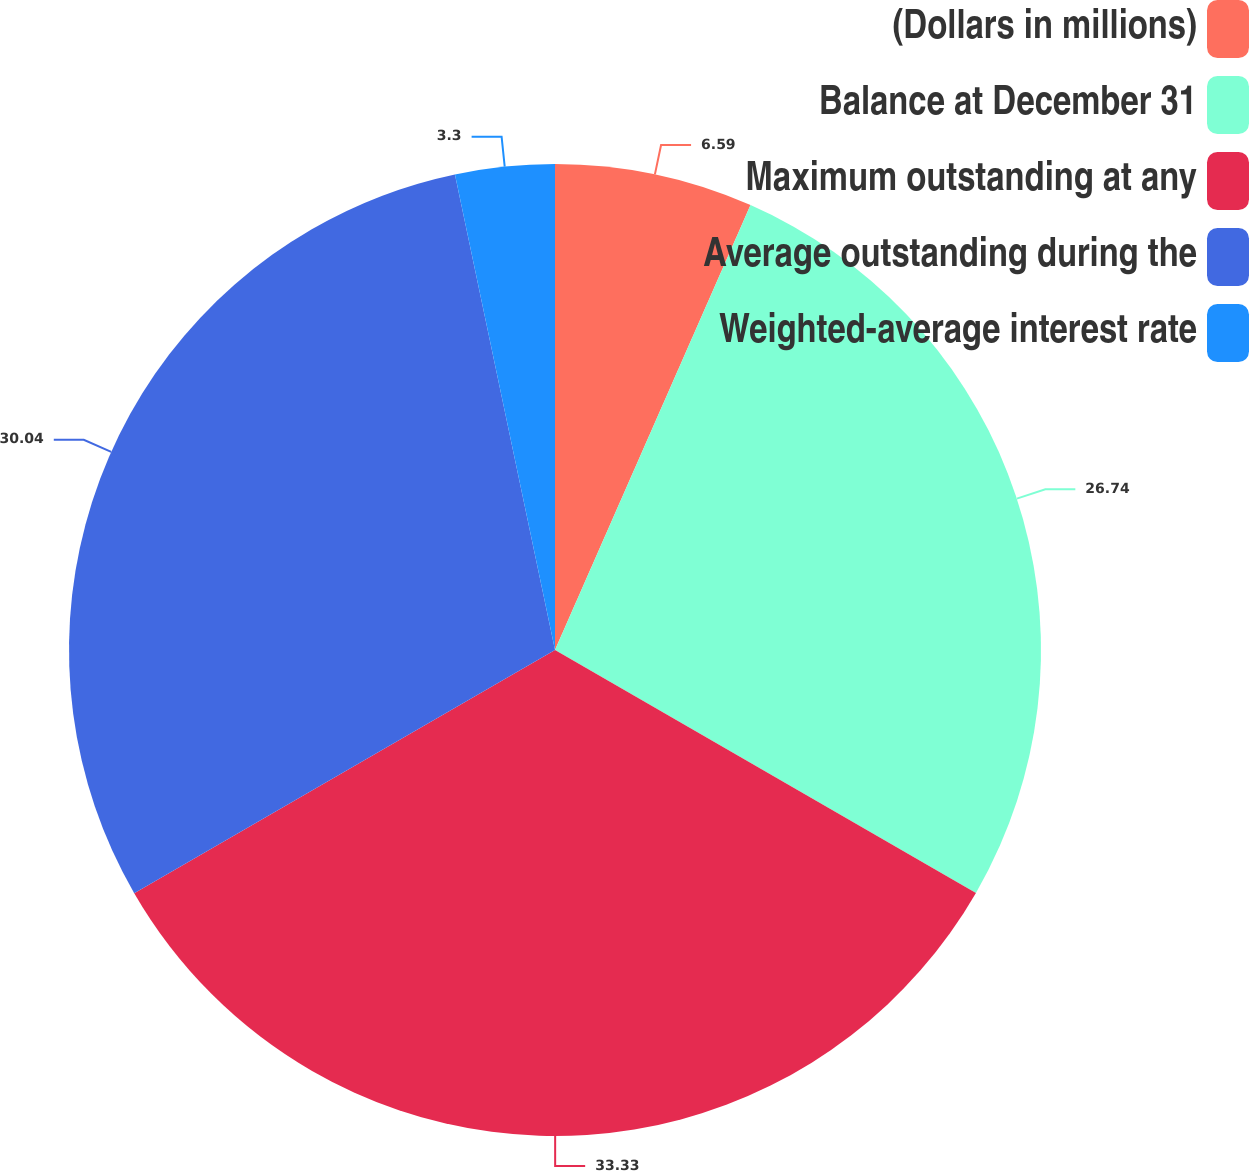Convert chart. <chart><loc_0><loc_0><loc_500><loc_500><pie_chart><fcel>(Dollars in millions)<fcel>Balance at December 31<fcel>Maximum outstanding at any<fcel>Average outstanding during the<fcel>Weighted-average interest rate<nl><fcel>6.59%<fcel>26.74%<fcel>33.33%<fcel>30.04%<fcel>3.3%<nl></chart> 